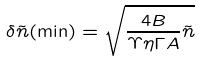Convert formula to latex. <formula><loc_0><loc_0><loc_500><loc_500>\delta \tilde { n } ( \min ) = \sqrt { \frac { 4 B } { \Upsilon \eta \Gamma A } \tilde { n } }</formula> 